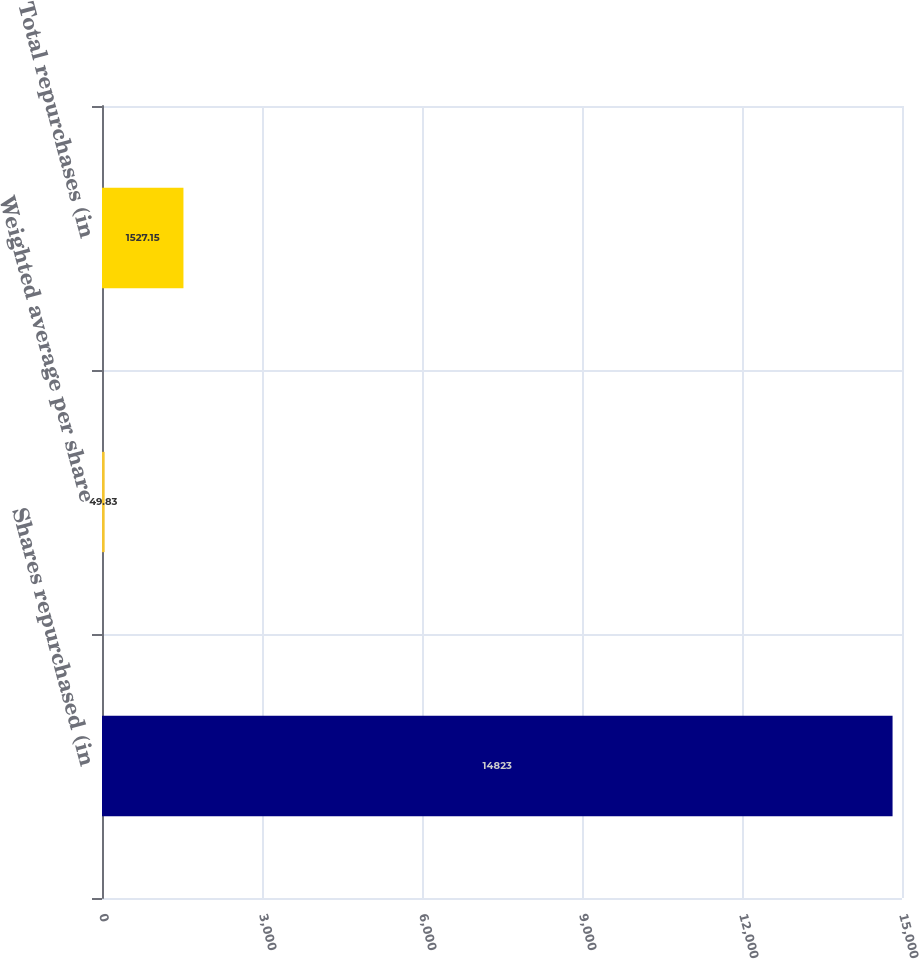Convert chart. <chart><loc_0><loc_0><loc_500><loc_500><bar_chart><fcel>Shares repurchased (in<fcel>Weighted average per share<fcel>Total repurchases (in<nl><fcel>14823<fcel>49.83<fcel>1527.15<nl></chart> 